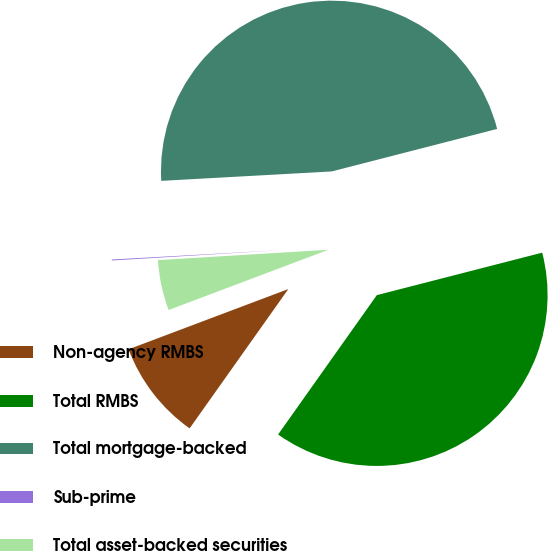Convert chart to OTSL. <chart><loc_0><loc_0><loc_500><loc_500><pie_chart><fcel>Non-agency RMBS<fcel>Total RMBS<fcel>Total mortgage-backed<fcel>Sub-prime<fcel>Total asset-backed securities<nl><fcel>9.45%<fcel>38.81%<fcel>46.87%<fcel>0.09%<fcel>4.77%<nl></chart> 